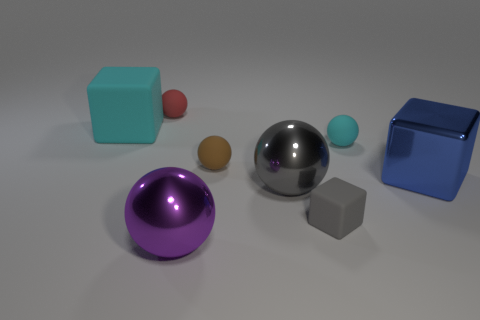What might be the purpose of this collection of objects? This collection of objects could serve multiple purposes. It might be a simple display portraying geometric shapes and the reflection properties of different materials, or it could potentially be a setup for a visual or physical experiment observing how light interacts with surfaces. Could these objects belong to a child's playset? Given their simple geometric shapes and variety of colors, it's conceivable that these objects could be part of an educational playset designed to teach children about shapes, sizes, and materials through sensory exploration. 